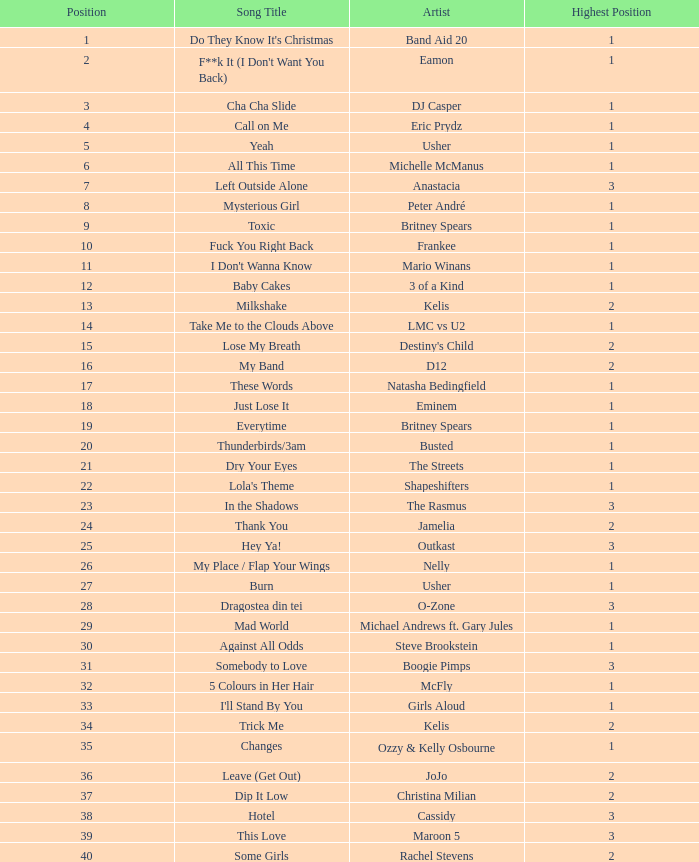What were the proceeds for dj casper when his position was under 13? 351421.0. 